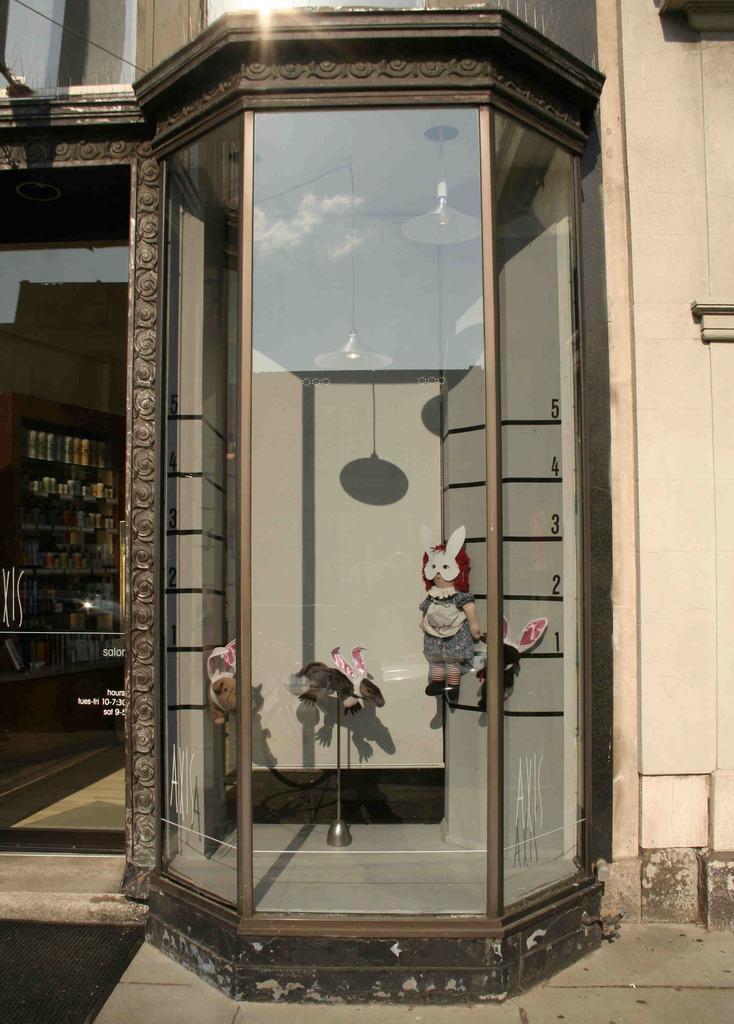How would you summarize this image in a sentence or two? In this image we can see toys placed on the stands in a glass room. We can also see electrical lights attached to the wall of the room. In the background we can see walls, floor, door and objects in the cupboard. 